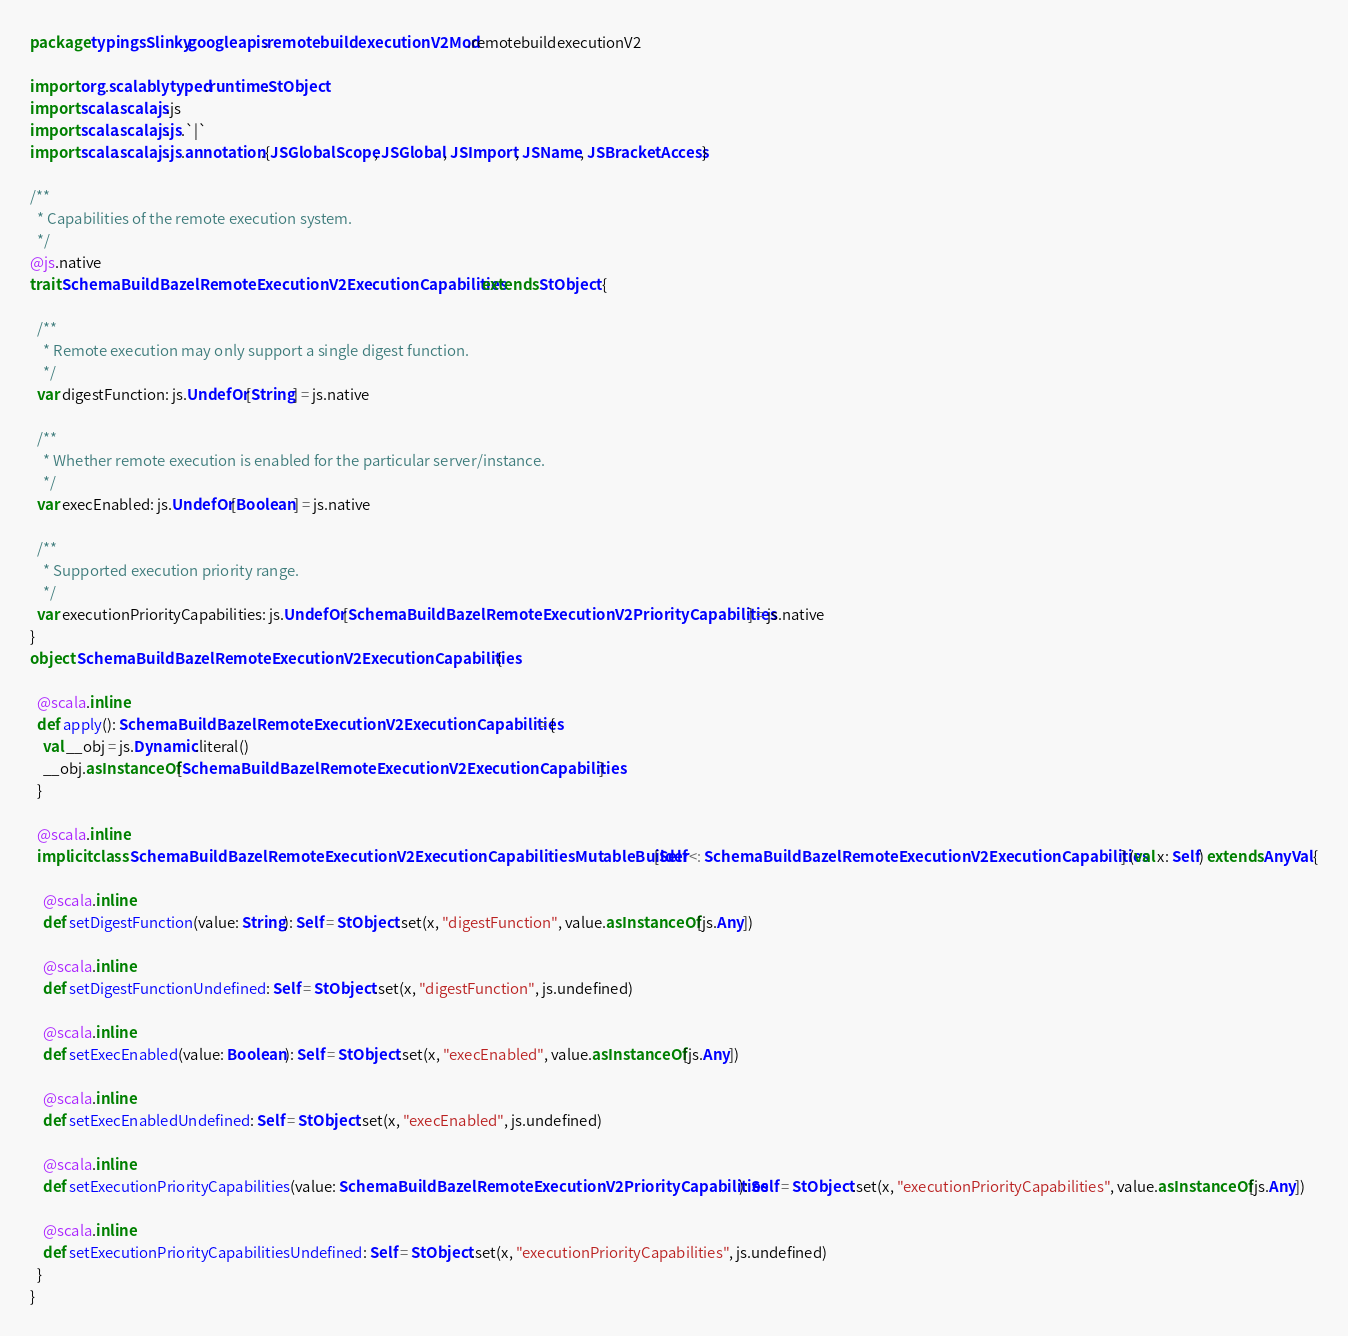Convert code to text. <code><loc_0><loc_0><loc_500><loc_500><_Scala_>package typingsSlinky.googleapis.remotebuildexecutionV2Mod.remotebuildexecutionV2

import org.scalablytyped.runtime.StObject
import scala.scalajs.js
import scala.scalajs.js.`|`
import scala.scalajs.js.annotation.{JSGlobalScope, JSGlobal, JSImport, JSName, JSBracketAccess}

/**
  * Capabilities of the remote execution system.
  */
@js.native
trait SchemaBuildBazelRemoteExecutionV2ExecutionCapabilities extends StObject {
  
  /**
    * Remote execution may only support a single digest function.
    */
  var digestFunction: js.UndefOr[String] = js.native
  
  /**
    * Whether remote execution is enabled for the particular server/instance.
    */
  var execEnabled: js.UndefOr[Boolean] = js.native
  
  /**
    * Supported execution priority range.
    */
  var executionPriorityCapabilities: js.UndefOr[SchemaBuildBazelRemoteExecutionV2PriorityCapabilities] = js.native
}
object SchemaBuildBazelRemoteExecutionV2ExecutionCapabilities {
  
  @scala.inline
  def apply(): SchemaBuildBazelRemoteExecutionV2ExecutionCapabilities = {
    val __obj = js.Dynamic.literal()
    __obj.asInstanceOf[SchemaBuildBazelRemoteExecutionV2ExecutionCapabilities]
  }
  
  @scala.inline
  implicit class SchemaBuildBazelRemoteExecutionV2ExecutionCapabilitiesMutableBuilder[Self <: SchemaBuildBazelRemoteExecutionV2ExecutionCapabilities] (val x: Self) extends AnyVal {
    
    @scala.inline
    def setDigestFunction(value: String): Self = StObject.set(x, "digestFunction", value.asInstanceOf[js.Any])
    
    @scala.inline
    def setDigestFunctionUndefined: Self = StObject.set(x, "digestFunction", js.undefined)
    
    @scala.inline
    def setExecEnabled(value: Boolean): Self = StObject.set(x, "execEnabled", value.asInstanceOf[js.Any])
    
    @scala.inline
    def setExecEnabledUndefined: Self = StObject.set(x, "execEnabled", js.undefined)
    
    @scala.inline
    def setExecutionPriorityCapabilities(value: SchemaBuildBazelRemoteExecutionV2PriorityCapabilities): Self = StObject.set(x, "executionPriorityCapabilities", value.asInstanceOf[js.Any])
    
    @scala.inline
    def setExecutionPriorityCapabilitiesUndefined: Self = StObject.set(x, "executionPriorityCapabilities", js.undefined)
  }
}
</code> 